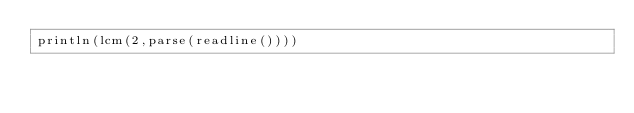Convert code to text. <code><loc_0><loc_0><loc_500><loc_500><_Julia_>println(lcm(2,parse(readline())))</code> 